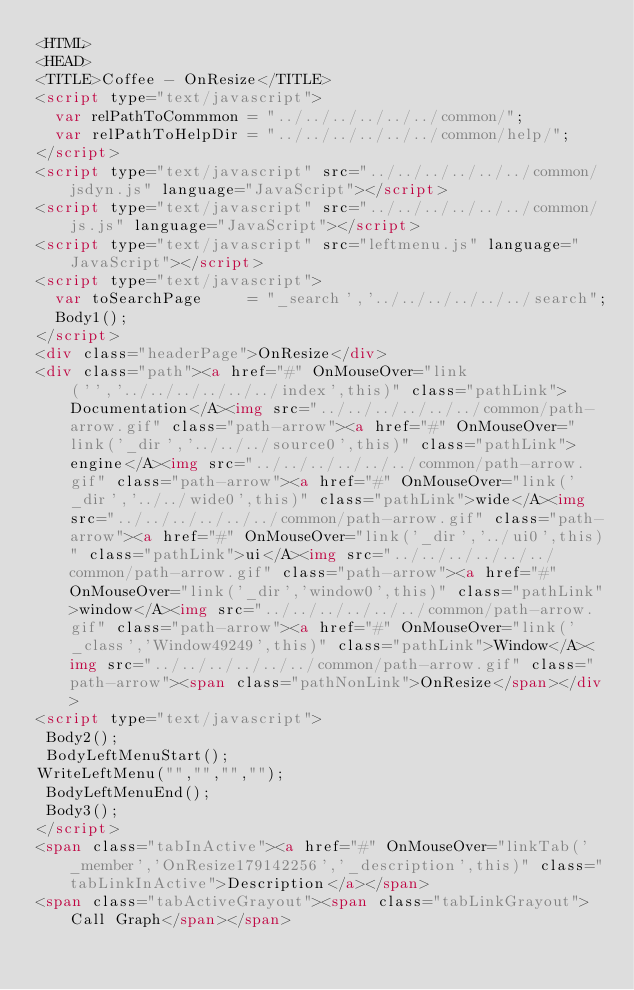Convert code to text. <code><loc_0><loc_0><loc_500><loc_500><_HTML_><HTML>
<HEAD>
<TITLE>Coffee - OnResize</TITLE>
<script type="text/javascript">
  var relPathToCommmon = "../../../../../../common/";
  var relPathToHelpDir = "../../../../../../common/help/";
</script>
<script type="text/javascript" src="../../../../../../common/jsdyn.js" language="JavaScript"></script>
<script type="text/javascript" src="../../../../../../common/js.js" language="JavaScript"></script>
<script type="text/javascript" src="leftmenu.js" language="JavaScript"></script>
<script type="text/javascript">
  var toSearchPage     = "_search','../../../../../../search";
  Body1();
</script>
<div class="headerPage">OnResize</div>
<div class="path"><a href="#" OnMouseOver="link('','../../../../../../index',this)" class="pathLink">Documentation</A><img src="../../../../../../common/path-arrow.gif" class="path-arrow"><a href="#" OnMouseOver="link('_dir','../../../source0',this)" class="pathLink">engine</A><img src="../../../../../../common/path-arrow.gif" class="path-arrow"><a href="#" OnMouseOver="link('_dir','../../wide0',this)" class="pathLink">wide</A><img src="../../../../../../common/path-arrow.gif" class="path-arrow"><a href="#" OnMouseOver="link('_dir','../ui0',this)" class="pathLink">ui</A><img src="../../../../../../common/path-arrow.gif" class="path-arrow"><a href="#" OnMouseOver="link('_dir','window0',this)" class="pathLink">window</A><img src="../../../../../../common/path-arrow.gif" class="path-arrow"><a href="#" OnMouseOver="link('_class','Window49249',this)" class="pathLink">Window</A><img src="../../../../../../common/path-arrow.gif" class="path-arrow"><span class="pathNonLink">OnResize</span></div>
<script type="text/javascript">
 Body2();
 BodyLeftMenuStart();
WriteLeftMenu("","","","");
 BodyLeftMenuEnd();
 Body3();
</script>
<span class="tabInActive"><a href="#" OnMouseOver="linkTab('_member','OnResize179142256','_description',this)" class="tabLinkInActive">Description</a></span>
<span class="tabActiveGrayout"><span class="tabLinkGrayout">Call Graph</span></span></code> 